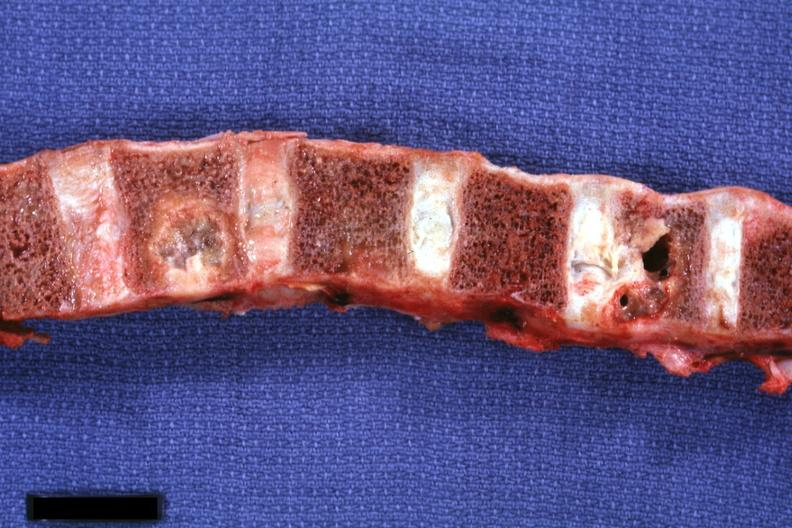what is present?
Answer the question using a single word or phrase. Joints 